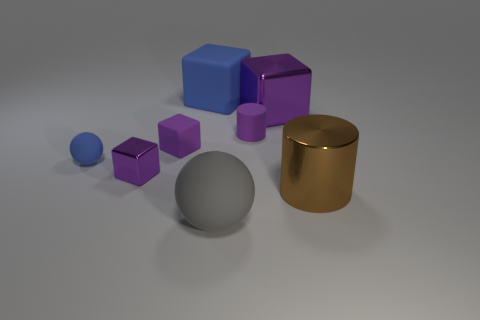Does the arrangement of the objects suggest any particular real-world application or is it purely abstract? The arrangement of the objects does not immediately suggest a real-world application; it appears to be an abstract composition. The shapes and materials are common in computer graphics demonstrations, often used to showcase rendering capabilities like lighting and shadow, reflections, and textures. 